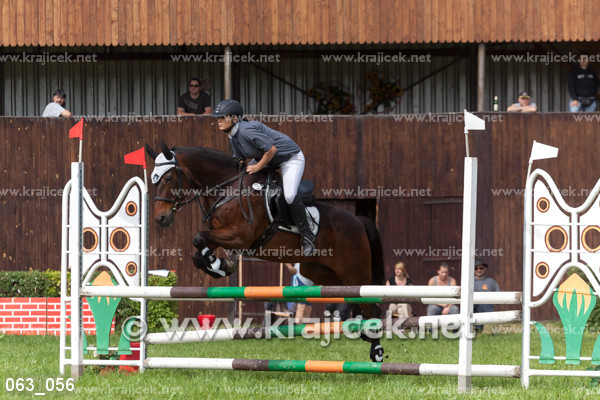What are some challenges a rider might face in a course like this one? Riders may encounter several challenges on a show jumping course. These include managing the horse's speed and momentum, taking turns accurately to approach each jump correctly, and maintaining the horse's focus amid distractions. Additionally, weather conditions and the course design, with its varying fence heights and distances, can impact a rider's strategy. 